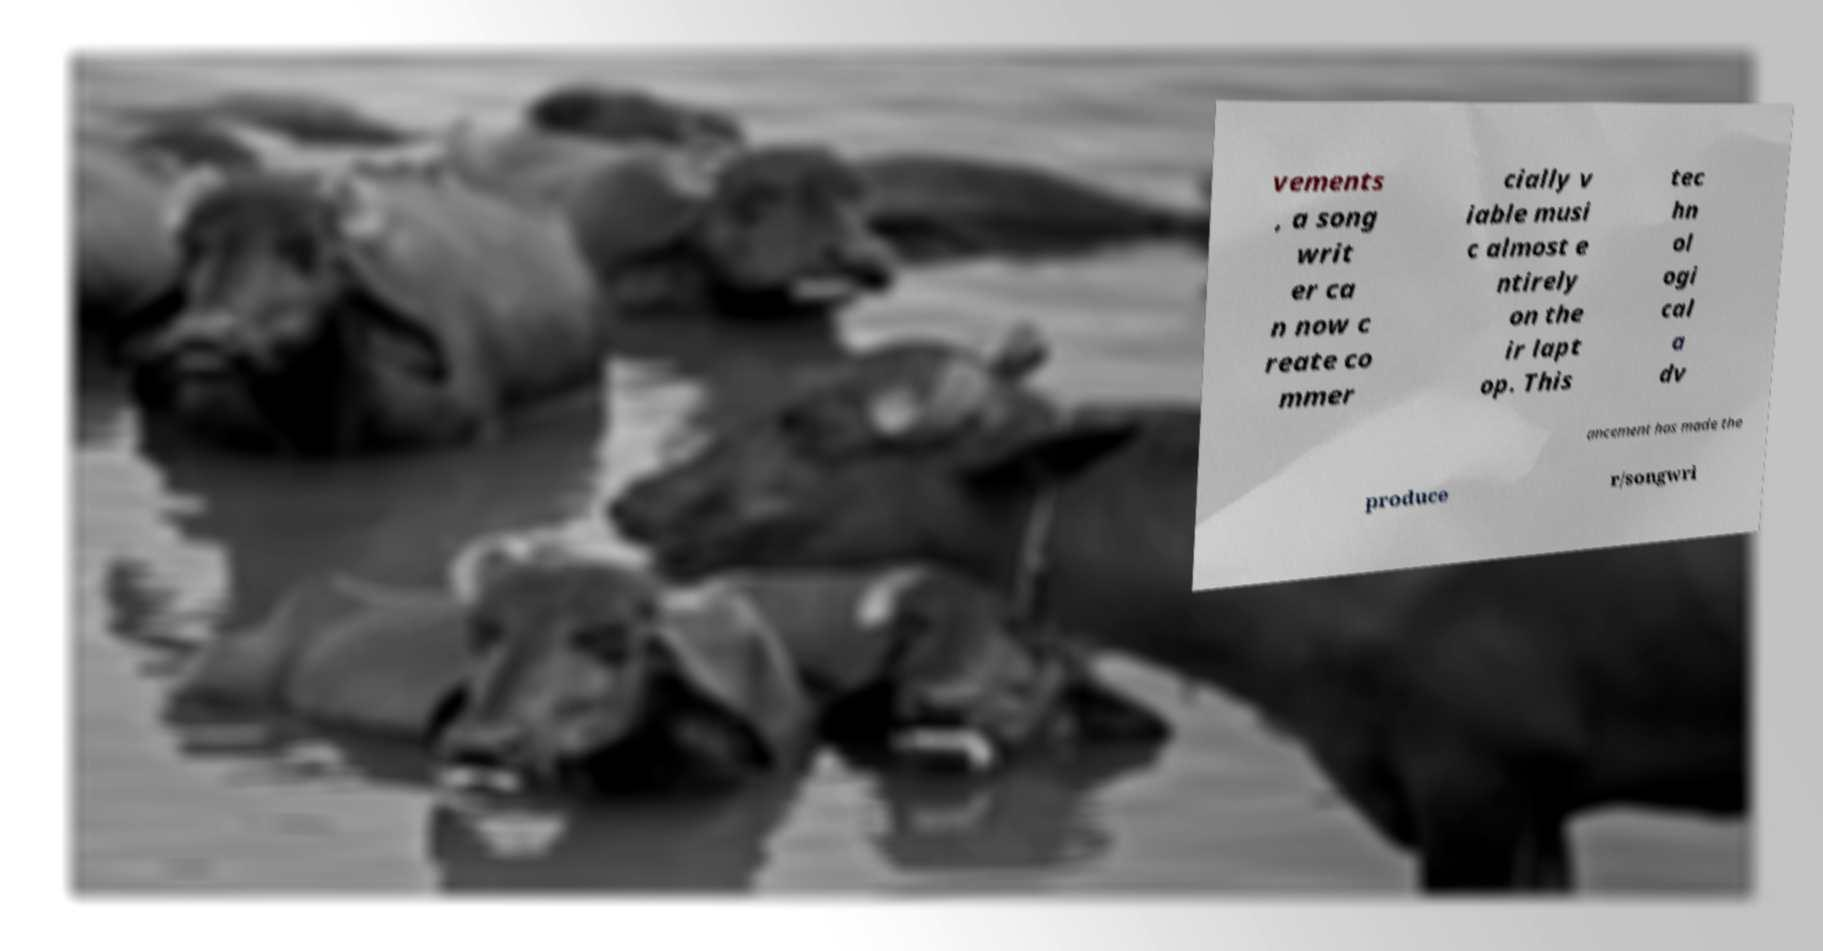I need the written content from this picture converted into text. Can you do that? vements , a song writ er ca n now c reate co mmer cially v iable musi c almost e ntirely on the ir lapt op. This tec hn ol ogi cal a dv ancement has made the produce r/songwri 